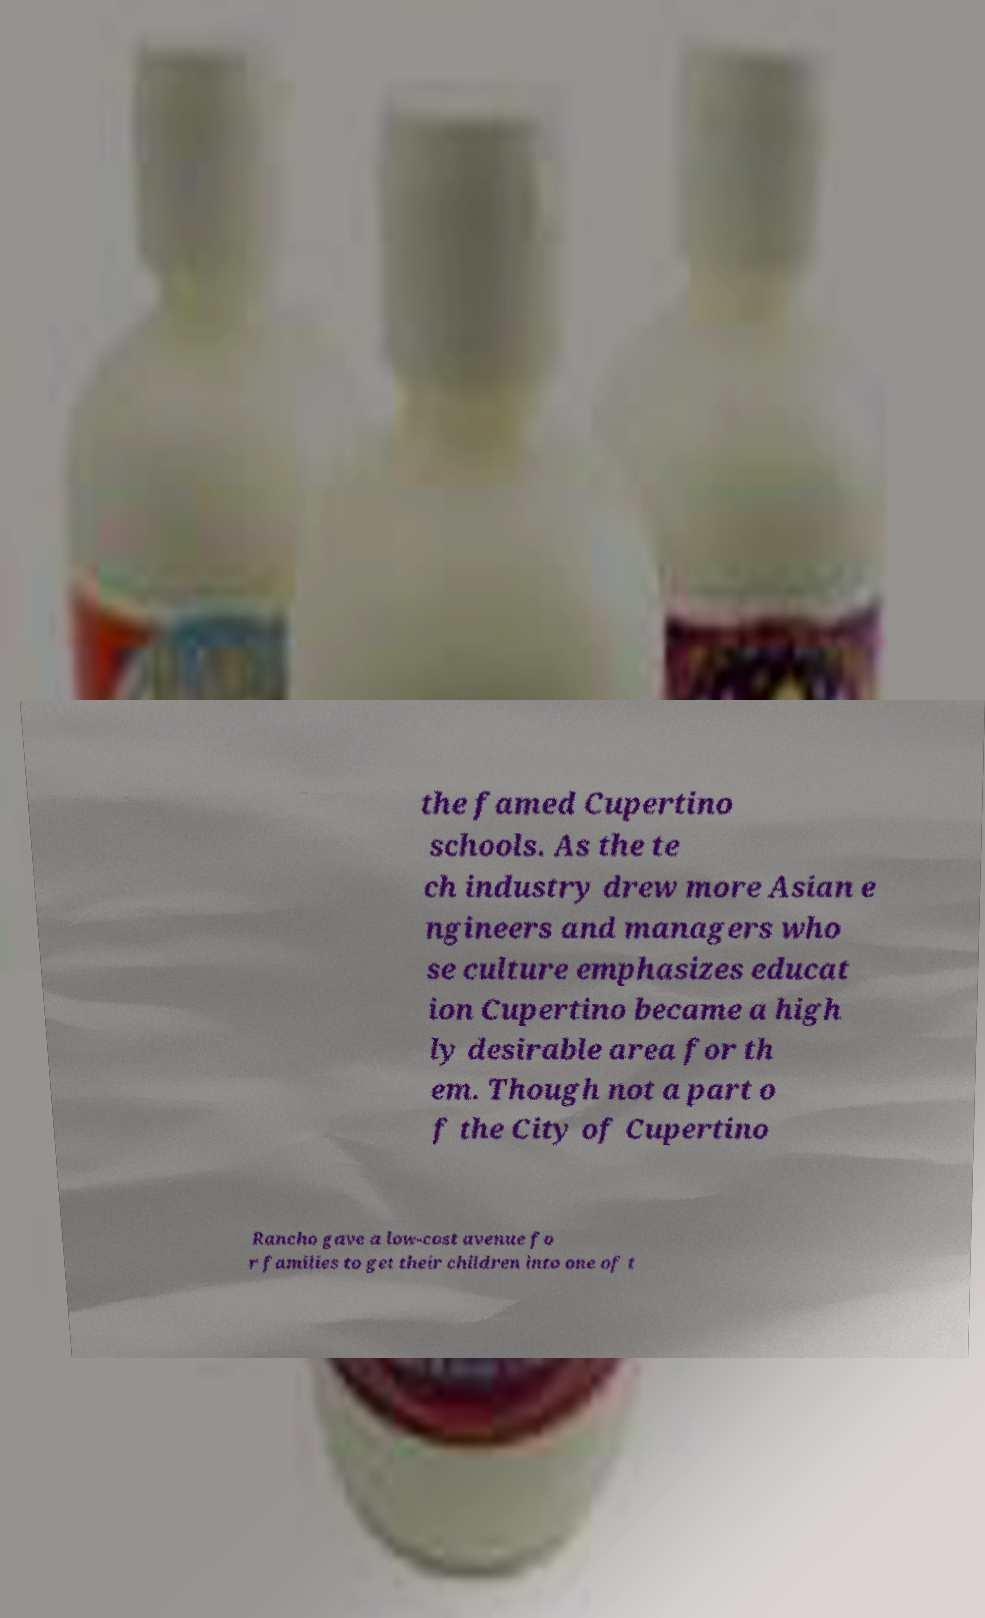Please identify and transcribe the text found in this image. the famed Cupertino schools. As the te ch industry drew more Asian e ngineers and managers who se culture emphasizes educat ion Cupertino became a high ly desirable area for th em. Though not a part o f the City of Cupertino Rancho gave a low-cost avenue fo r families to get their children into one of t 